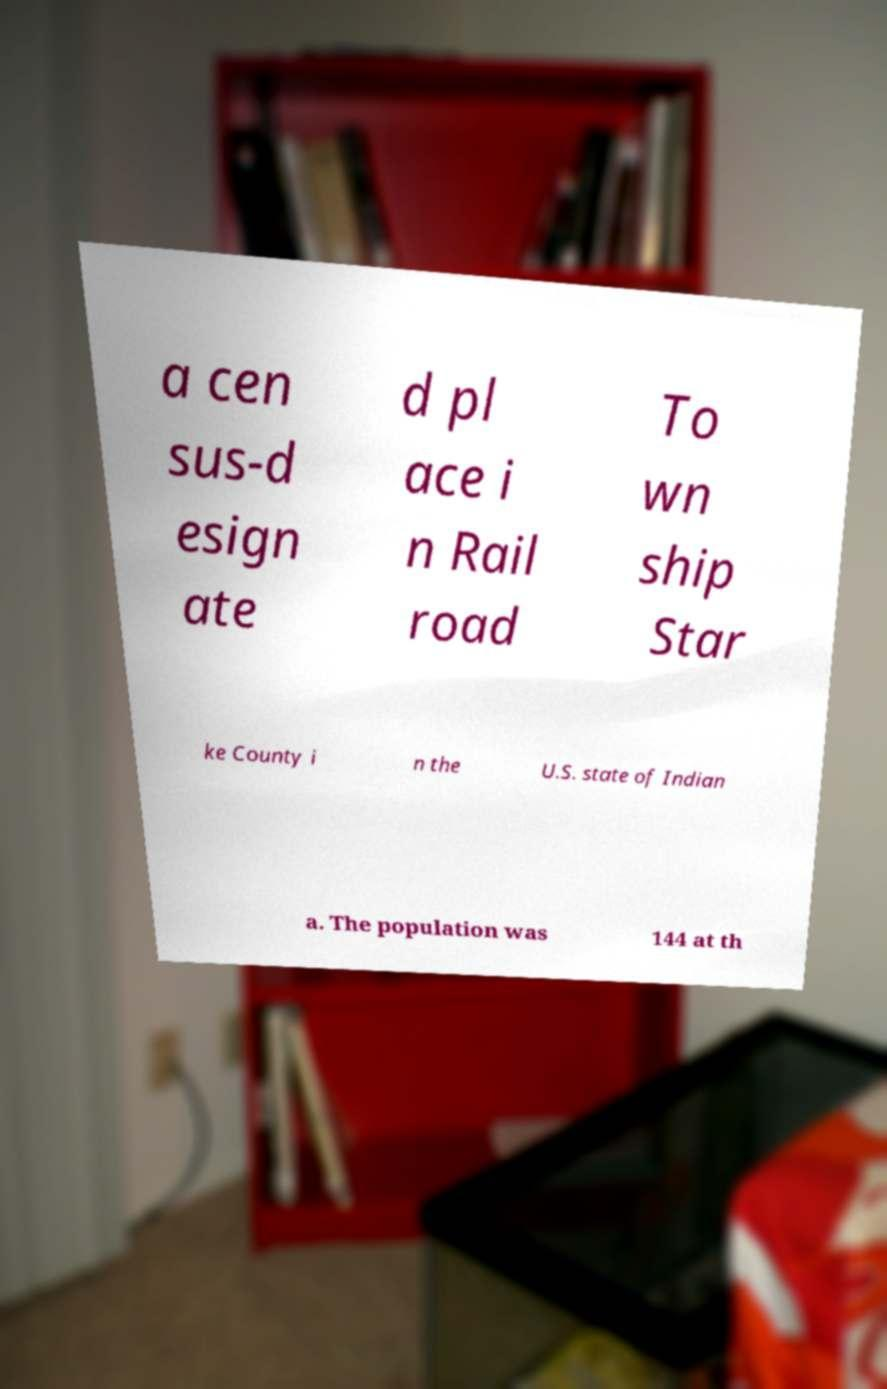Can you read and provide the text displayed in the image?This photo seems to have some interesting text. Can you extract and type it out for me? a cen sus-d esign ate d pl ace i n Rail road To wn ship Star ke County i n the U.S. state of Indian a. The population was 144 at th 